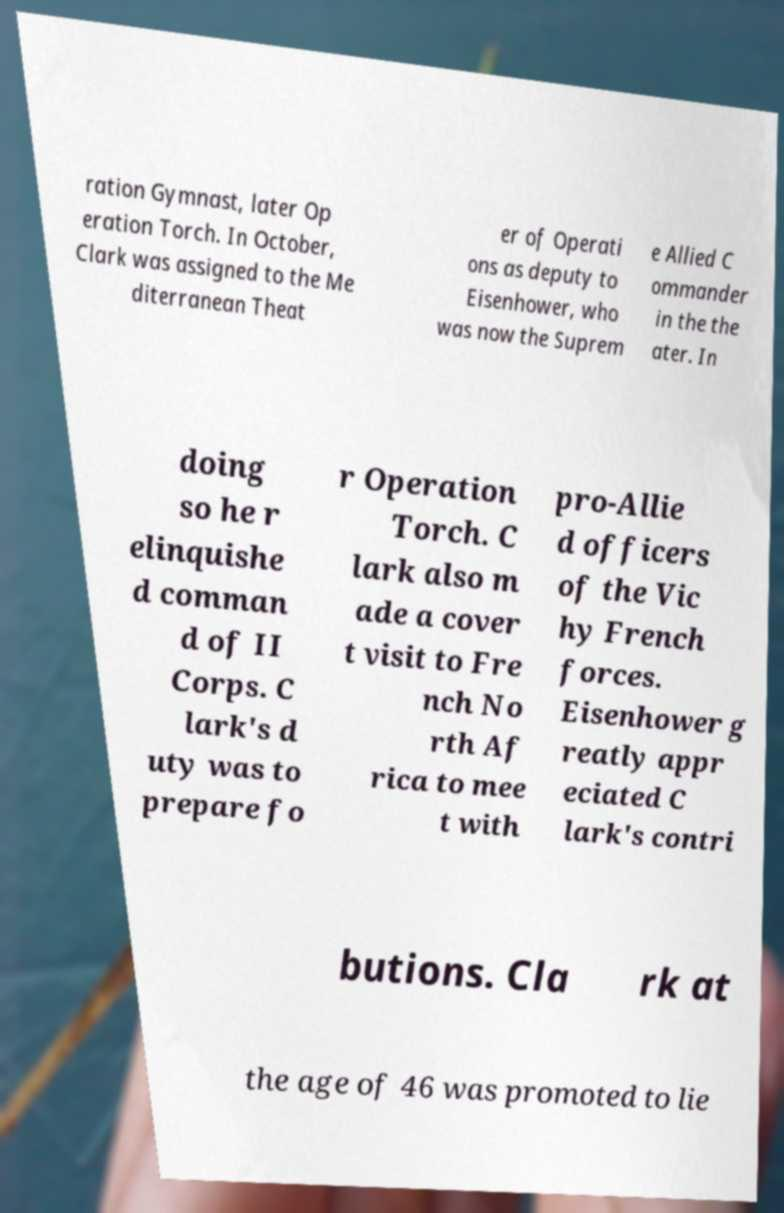There's text embedded in this image that I need extracted. Can you transcribe it verbatim? ration Gymnast, later Op eration Torch. In October, Clark was assigned to the Me diterranean Theat er of Operati ons as deputy to Eisenhower, who was now the Suprem e Allied C ommander in the the ater. In doing so he r elinquishe d comman d of II Corps. C lark's d uty was to prepare fo r Operation Torch. C lark also m ade a cover t visit to Fre nch No rth Af rica to mee t with pro-Allie d officers of the Vic hy French forces. Eisenhower g reatly appr eciated C lark's contri butions. Cla rk at the age of 46 was promoted to lie 